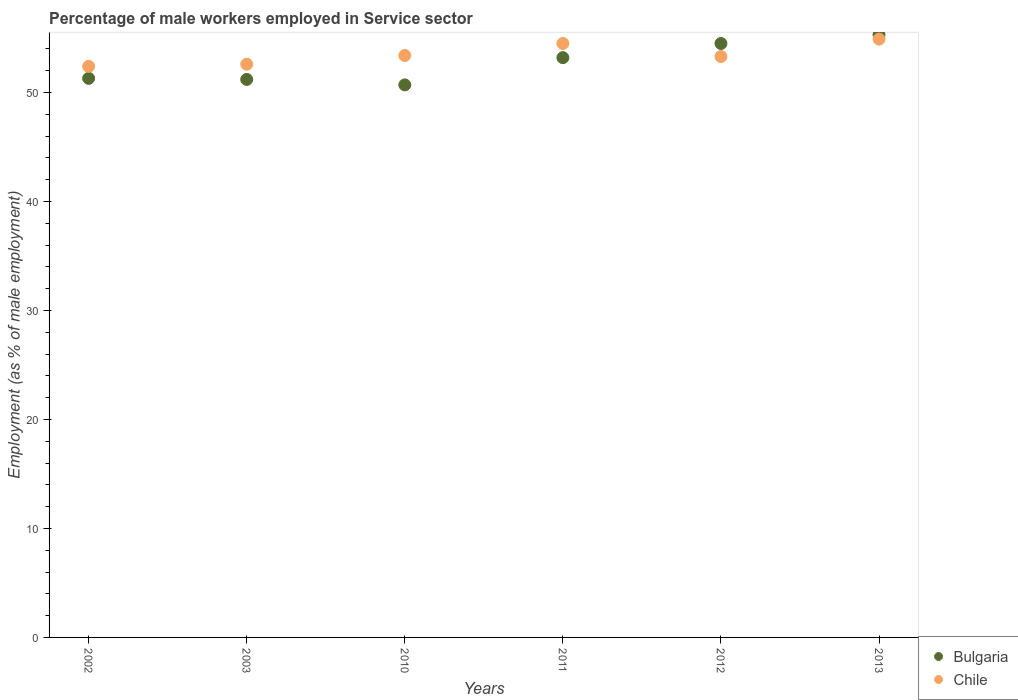Is the number of dotlines equal to the number of legend labels?
Ensure brevity in your answer.  Yes. What is the percentage of male workers employed in Service sector in Chile in 2012?
Offer a terse response. 53.3. Across all years, what is the maximum percentage of male workers employed in Service sector in Chile?
Make the answer very short. 54.9. Across all years, what is the minimum percentage of male workers employed in Service sector in Bulgaria?
Give a very brief answer. 50.7. In which year was the percentage of male workers employed in Service sector in Chile maximum?
Offer a terse response. 2013. In which year was the percentage of male workers employed in Service sector in Bulgaria minimum?
Offer a terse response. 2010. What is the total percentage of male workers employed in Service sector in Chile in the graph?
Offer a terse response. 321.1. What is the difference between the percentage of male workers employed in Service sector in Bulgaria in 2011 and the percentage of male workers employed in Service sector in Chile in 2013?
Keep it short and to the point. -1.7. What is the average percentage of male workers employed in Service sector in Bulgaria per year?
Ensure brevity in your answer.  52.7. In the year 2010, what is the difference between the percentage of male workers employed in Service sector in Bulgaria and percentage of male workers employed in Service sector in Chile?
Offer a very short reply. -2.7. In how many years, is the percentage of male workers employed in Service sector in Bulgaria greater than 38 %?
Provide a succinct answer. 6. What is the ratio of the percentage of male workers employed in Service sector in Bulgaria in 2003 to that in 2012?
Give a very brief answer. 0.94. Is the difference between the percentage of male workers employed in Service sector in Bulgaria in 2002 and 2003 greater than the difference between the percentage of male workers employed in Service sector in Chile in 2002 and 2003?
Keep it short and to the point. Yes. What is the difference between the highest and the second highest percentage of male workers employed in Service sector in Bulgaria?
Provide a short and direct response. 0.8. What is the difference between the highest and the lowest percentage of male workers employed in Service sector in Bulgaria?
Offer a terse response. 4.6. In how many years, is the percentage of male workers employed in Service sector in Bulgaria greater than the average percentage of male workers employed in Service sector in Bulgaria taken over all years?
Ensure brevity in your answer.  3. Does the percentage of male workers employed in Service sector in Chile monotonically increase over the years?
Make the answer very short. No. How many years are there in the graph?
Keep it short and to the point. 6. What is the title of the graph?
Offer a very short reply. Percentage of male workers employed in Service sector. Does "Kosovo" appear as one of the legend labels in the graph?
Keep it short and to the point. No. What is the label or title of the Y-axis?
Make the answer very short. Employment (as % of male employment). What is the Employment (as % of male employment) of Bulgaria in 2002?
Provide a succinct answer. 51.3. What is the Employment (as % of male employment) in Chile in 2002?
Your answer should be very brief. 52.4. What is the Employment (as % of male employment) of Bulgaria in 2003?
Provide a succinct answer. 51.2. What is the Employment (as % of male employment) in Chile in 2003?
Keep it short and to the point. 52.6. What is the Employment (as % of male employment) of Bulgaria in 2010?
Ensure brevity in your answer.  50.7. What is the Employment (as % of male employment) of Chile in 2010?
Provide a short and direct response. 53.4. What is the Employment (as % of male employment) in Bulgaria in 2011?
Your response must be concise. 53.2. What is the Employment (as % of male employment) in Chile in 2011?
Provide a succinct answer. 54.5. What is the Employment (as % of male employment) of Bulgaria in 2012?
Keep it short and to the point. 54.5. What is the Employment (as % of male employment) of Chile in 2012?
Your answer should be compact. 53.3. What is the Employment (as % of male employment) in Bulgaria in 2013?
Offer a terse response. 55.3. What is the Employment (as % of male employment) of Chile in 2013?
Your response must be concise. 54.9. Across all years, what is the maximum Employment (as % of male employment) of Bulgaria?
Offer a terse response. 55.3. Across all years, what is the maximum Employment (as % of male employment) of Chile?
Your answer should be compact. 54.9. Across all years, what is the minimum Employment (as % of male employment) in Bulgaria?
Make the answer very short. 50.7. Across all years, what is the minimum Employment (as % of male employment) in Chile?
Your answer should be compact. 52.4. What is the total Employment (as % of male employment) in Bulgaria in the graph?
Offer a terse response. 316.2. What is the total Employment (as % of male employment) of Chile in the graph?
Your answer should be very brief. 321.1. What is the difference between the Employment (as % of male employment) of Chile in 2002 and that in 2010?
Your response must be concise. -1. What is the difference between the Employment (as % of male employment) in Bulgaria in 2002 and that in 2012?
Your answer should be very brief. -3.2. What is the difference between the Employment (as % of male employment) of Bulgaria in 2003 and that in 2010?
Your response must be concise. 0.5. What is the difference between the Employment (as % of male employment) in Bulgaria in 2003 and that in 2012?
Keep it short and to the point. -3.3. What is the difference between the Employment (as % of male employment) of Chile in 2003 and that in 2012?
Offer a very short reply. -0.7. What is the difference between the Employment (as % of male employment) in Bulgaria in 2010 and that in 2013?
Make the answer very short. -4.6. What is the difference between the Employment (as % of male employment) of Chile in 2010 and that in 2013?
Make the answer very short. -1.5. What is the difference between the Employment (as % of male employment) in Bulgaria in 2011 and that in 2012?
Make the answer very short. -1.3. What is the difference between the Employment (as % of male employment) in Chile in 2011 and that in 2012?
Your answer should be very brief. 1.2. What is the difference between the Employment (as % of male employment) in Bulgaria in 2011 and that in 2013?
Provide a short and direct response. -2.1. What is the difference between the Employment (as % of male employment) of Chile in 2012 and that in 2013?
Your response must be concise. -1.6. What is the difference between the Employment (as % of male employment) of Bulgaria in 2002 and the Employment (as % of male employment) of Chile in 2003?
Make the answer very short. -1.3. What is the difference between the Employment (as % of male employment) of Bulgaria in 2002 and the Employment (as % of male employment) of Chile in 2010?
Offer a terse response. -2.1. What is the difference between the Employment (as % of male employment) of Bulgaria in 2002 and the Employment (as % of male employment) of Chile in 2011?
Your answer should be very brief. -3.2. What is the difference between the Employment (as % of male employment) in Bulgaria in 2002 and the Employment (as % of male employment) in Chile in 2013?
Your response must be concise. -3.6. What is the difference between the Employment (as % of male employment) of Bulgaria in 2003 and the Employment (as % of male employment) of Chile in 2010?
Ensure brevity in your answer.  -2.2. What is the difference between the Employment (as % of male employment) in Bulgaria in 2003 and the Employment (as % of male employment) in Chile in 2011?
Your answer should be compact. -3.3. What is the difference between the Employment (as % of male employment) in Bulgaria in 2011 and the Employment (as % of male employment) in Chile in 2012?
Your answer should be very brief. -0.1. What is the difference between the Employment (as % of male employment) in Bulgaria in 2011 and the Employment (as % of male employment) in Chile in 2013?
Offer a very short reply. -1.7. What is the average Employment (as % of male employment) of Bulgaria per year?
Give a very brief answer. 52.7. What is the average Employment (as % of male employment) in Chile per year?
Offer a terse response. 53.52. In the year 2003, what is the difference between the Employment (as % of male employment) in Bulgaria and Employment (as % of male employment) in Chile?
Offer a terse response. -1.4. In the year 2010, what is the difference between the Employment (as % of male employment) in Bulgaria and Employment (as % of male employment) in Chile?
Ensure brevity in your answer.  -2.7. In the year 2011, what is the difference between the Employment (as % of male employment) of Bulgaria and Employment (as % of male employment) of Chile?
Provide a succinct answer. -1.3. What is the ratio of the Employment (as % of male employment) in Chile in 2002 to that in 2003?
Ensure brevity in your answer.  1. What is the ratio of the Employment (as % of male employment) of Bulgaria in 2002 to that in 2010?
Your response must be concise. 1.01. What is the ratio of the Employment (as % of male employment) in Chile in 2002 to that in 2010?
Give a very brief answer. 0.98. What is the ratio of the Employment (as % of male employment) of Bulgaria in 2002 to that in 2011?
Ensure brevity in your answer.  0.96. What is the ratio of the Employment (as % of male employment) of Chile in 2002 to that in 2011?
Offer a terse response. 0.96. What is the ratio of the Employment (as % of male employment) in Bulgaria in 2002 to that in 2012?
Your response must be concise. 0.94. What is the ratio of the Employment (as % of male employment) of Chile in 2002 to that in 2012?
Your answer should be compact. 0.98. What is the ratio of the Employment (as % of male employment) of Bulgaria in 2002 to that in 2013?
Make the answer very short. 0.93. What is the ratio of the Employment (as % of male employment) in Chile in 2002 to that in 2013?
Your response must be concise. 0.95. What is the ratio of the Employment (as % of male employment) in Bulgaria in 2003 to that in 2010?
Ensure brevity in your answer.  1.01. What is the ratio of the Employment (as % of male employment) in Chile in 2003 to that in 2010?
Offer a very short reply. 0.98. What is the ratio of the Employment (as % of male employment) of Bulgaria in 2003 to that in 2011?
Keep it short and to the point. 0.96. What is the ratio of the Employment (as % of male employment) in Chile in 2003 to that in 2011?
Your answer should be compact. 0.97. What is the ratio of the Employment (as % of male employment) of Bulgaria in 2003 to that in 2012?
Keep it short and to the point. 0.94. What is the ratio of the Employment (as % of male employment) of Chile in 2003 to that in 2012?
Ensure brevity in your answer.  0.99. What is the ratio of the Employment (as % of male employment) of Bulgaria in 2003 to that in 2013?
Your answer should be compact. 0.93. What is the ratio of the Employment (as % of male employment) of Chile in 2003 to that in 2013?
Ensure brevity in your answer.  0.96. What is the ratio of the Employment (as % of male employment) in Bulgaria in 2010 to that in 2011?
Offer a very short reply. 0.95. What is the ratio of the Employment (as % of male employment) in Chile in 2010 to that in 2011?
Ensure brevity in your answer.  0.98. What is the ratio of the Employment (as % of male employment) of Bulgaria in 2010 to that in 2012?
Provide a short and direct response. 0.93. What is the ratio of the Employment (as % of male employment) of Bulgaria in 2010 to that in 2013?
Ensure brevity in your answer.  0.92. What is the ratio of the Employment (as % of male employment) in Chile in 2010 to that in 2013?
Ensure brevity in your answer.  0.97. What is the ratio of the Employment (as % of male employment) in Bulgaria in 2011 to that in 2012?
Give a very brief answer. 0.98. What is the ratio of the Employment (as % of male employment) of Chile in 2011 to that in 2012?
Keep it short and to the point. 1.02. What is the ratio of the Employment (as % of male employment) of Chile in 2011 to that in 2013?
Offer a very short reply. 0.99. What is the ratio of the Employment (as % of male employment) in Bulgaria in 2012 to that in 2013?
Ensure brevity in your answer.  0.99. What is the ratio of the Employment (as % of male employment) of Chile in 2012 to that in 2013?
Keep it short and to the point. 0.97. 